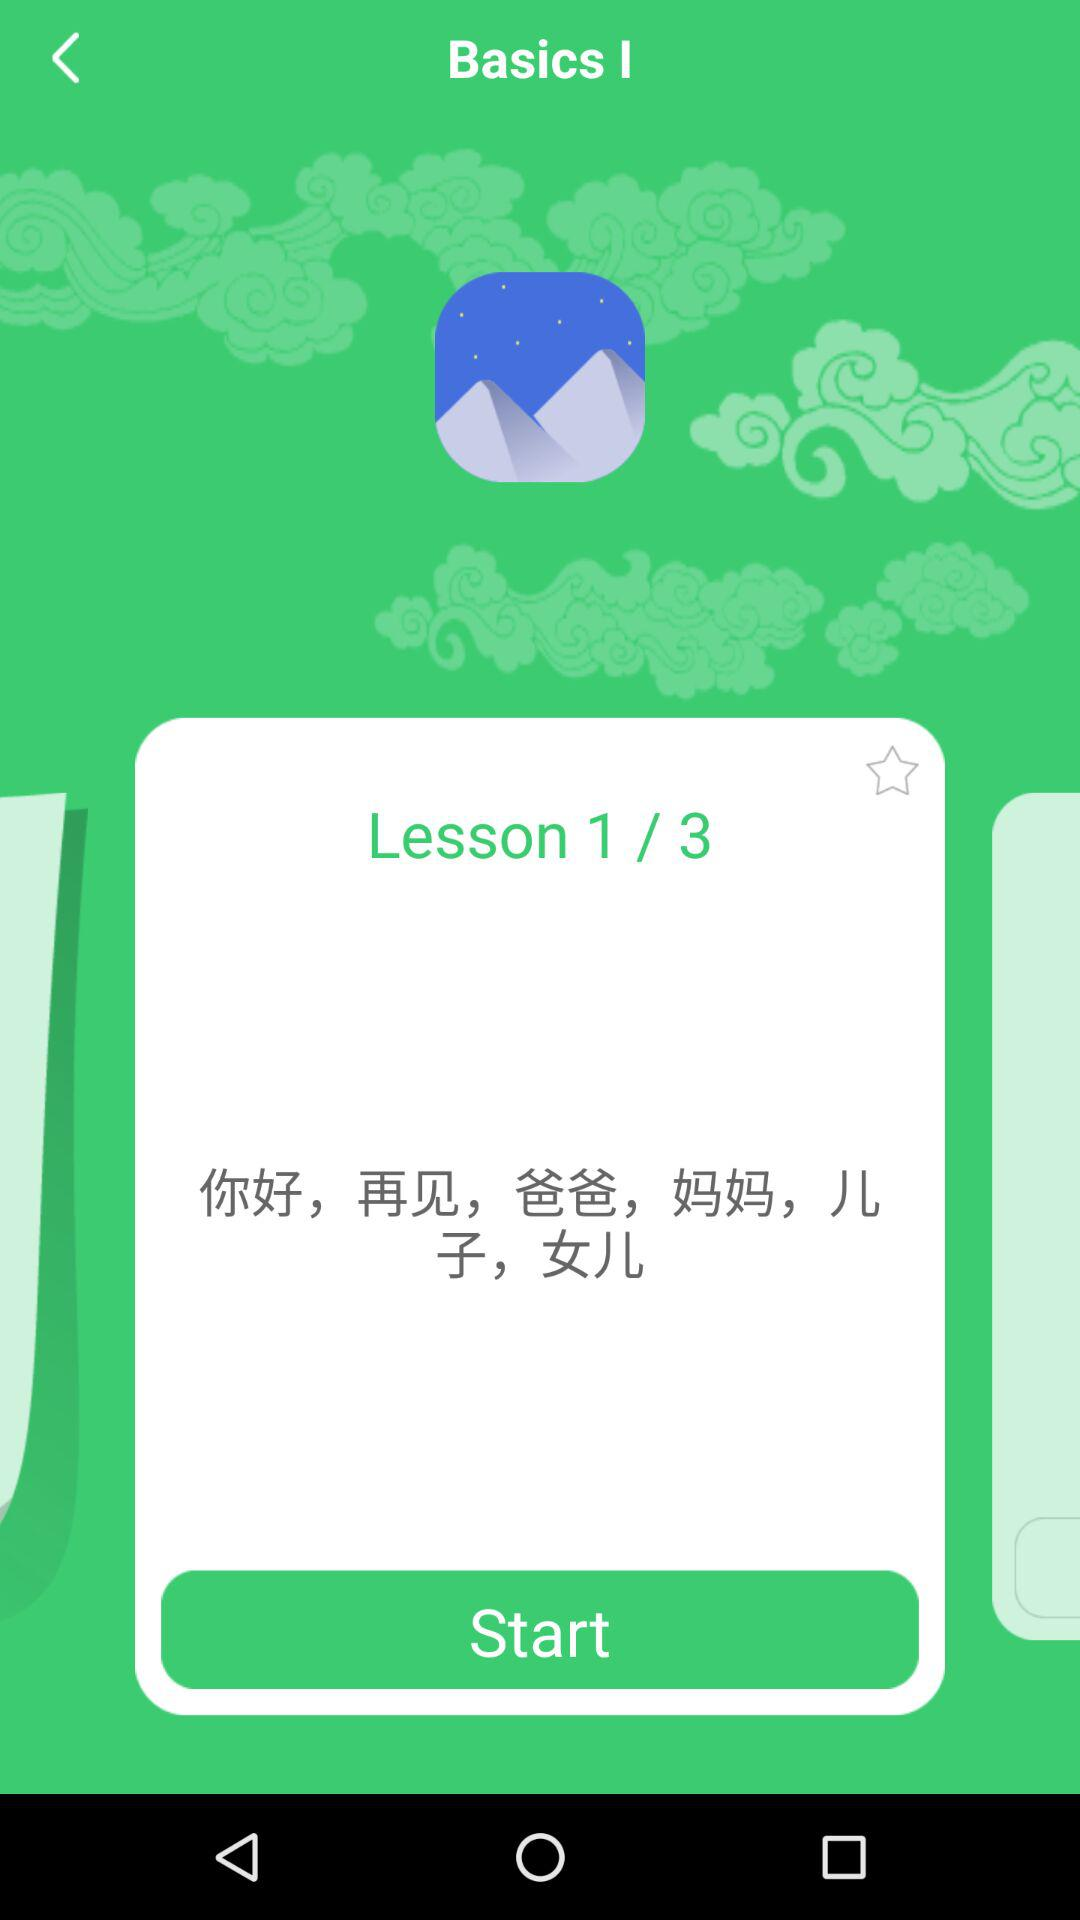What is the number of the current lesson? The number of the current lesson is 1. 